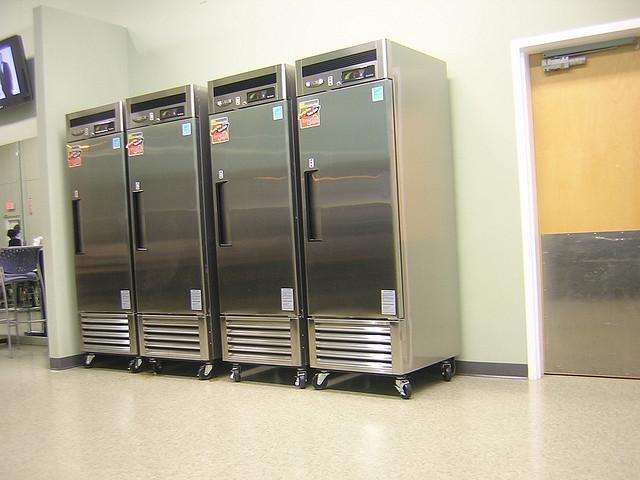Where is this scene taking place?
Pick the correct solution from the four options below to address the question.
Options: House, store, cafeteria, furniture store. Cafeteria. What temperature do these devices keep things?
From the following four choices, select the correct answer to address the question.
Options: Hot, boiling, cold, room. Cold. 